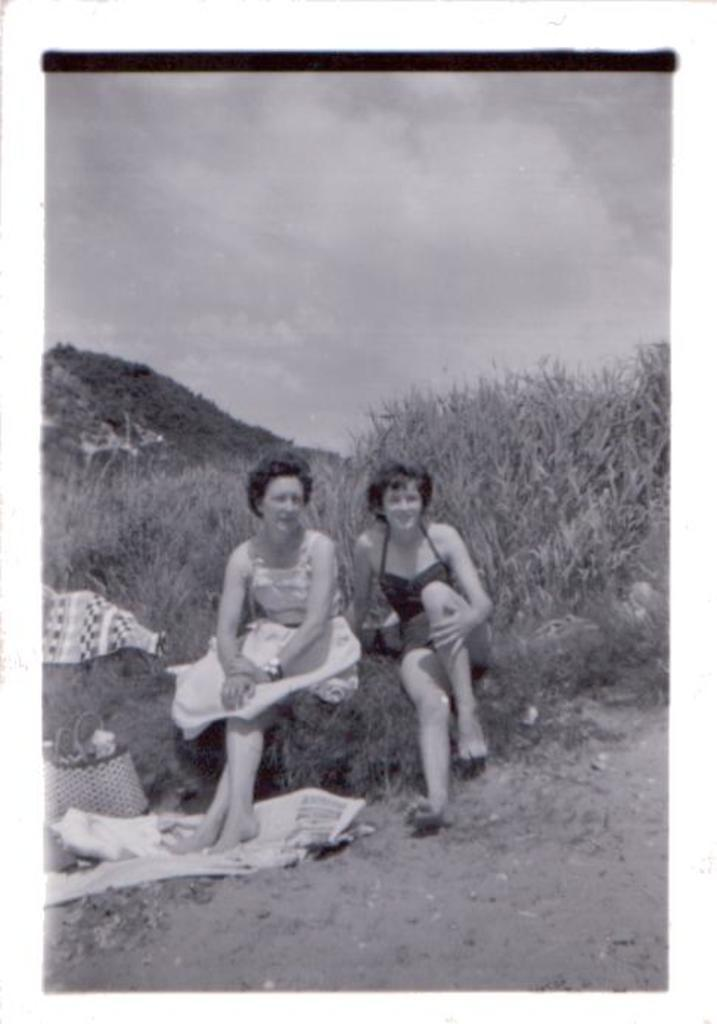What are the people in the image doing? The people in the image are sitting in the center. What can be seen on the left side of the image? There is a basket on the left side of the image. What is visible in the background of the image? Hills and the sky are visible in the background of the image. What type of terrain is present in the image? There is grass in the image. Where is the nearest airport to the location in the image? The image does not provide information about the location or the nearest airport. What type of stamp can be seen on the grass in the image? There is no stamp present on the grass in the image. 